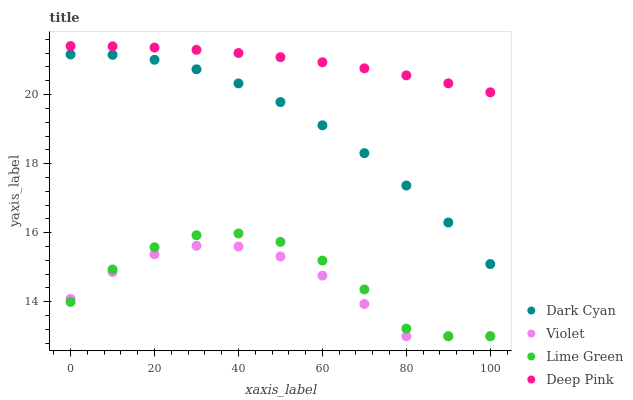Does Violet have the minimum area under the curve?
Answer yes or no. Yes. Does Deep Pink have the maximum area under the curve?
Answer yes or no. Yes. Does Lime Green have the minimum area under the curve?
Answer yes or no. No. Does Lime Green have the maximum area under the curve?
Answer yes or no. No. Is Deep Pink the smoothest?
Answer yes or no. Yes. Is Lime Green the roughest?
Answer yes or no. Yes. Is Lime Green the smoothest?
Answer yes or no. No. Is Deep Pink the roughest?
Answer yes or no. No. Does Lime Green have the lowest value?
Answer yes or no. Yes. Does Deep Pink have the lowest value?
Answer yes or no. No. Does Deep Pink have the highest value?
Answer yes or no. Yes. Does Lime Green have the highest value?
Answer yes or no. No. Is Dark Cyan less than Deep Pink?
Answer yes or no. Yes. Is Deep Pink greater than Dark Cyan?
Answer yes or no. Yes. Does Violet intersect Lime Green?
Answer yes or no. Yes. Is Violet less than Lime Green?
Answer yes or no. No. Is Violet greater than Lime Green?
Answer yes or no. No. Does Dark Cyan intersect Deep Pink?
Answer yes or no. No. 